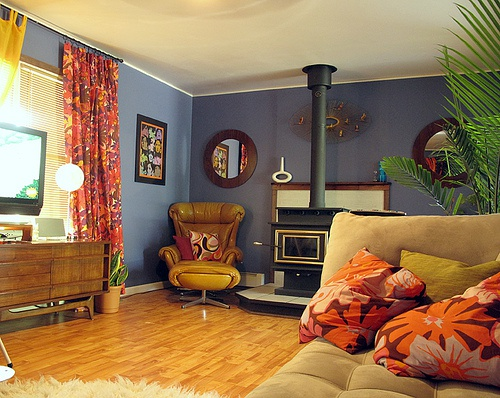Describe the objects in this image and their specific colors. I can see couch in tan, olive, red, and maroon tones, potted plant in tan, darkgreen, black, and gray tones, chair in tan, maroon, olive, and black tones, tv in tan, white, gray, and turquoise tones, and potted plant in tan, black, orange, red, and darkgreen tones in this image. 